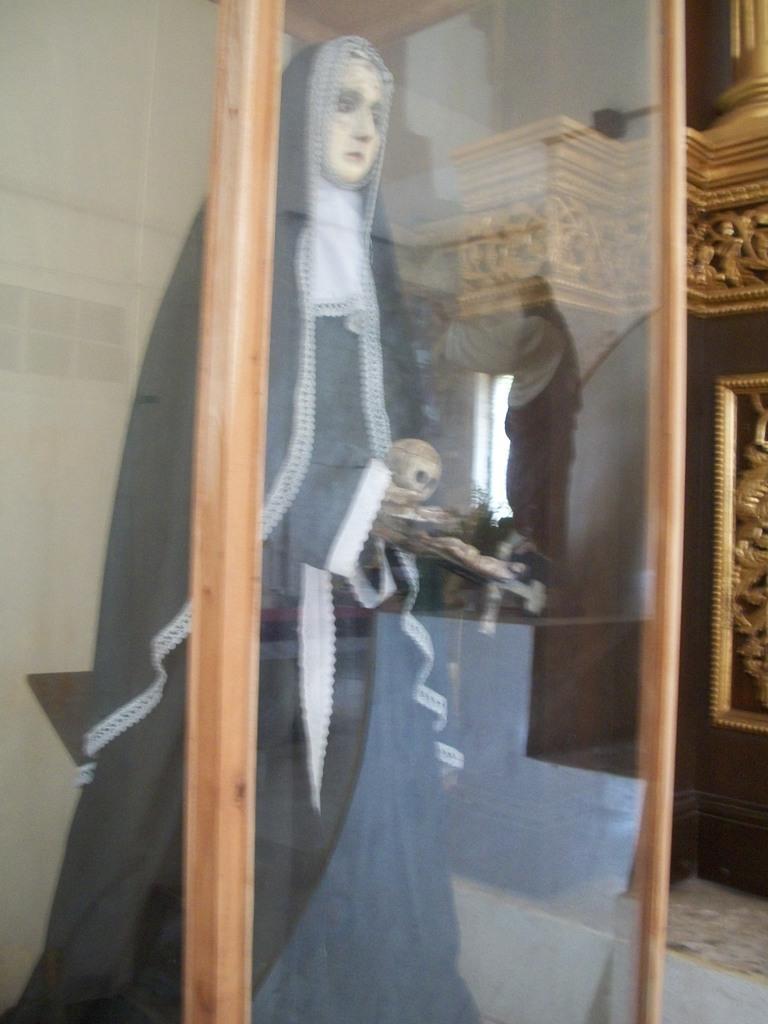Can you describe this image briefly? In the foreground we can see a glass case, inside the glass there is a sculpture. On the right there are wooden sculptures, window and wall. 